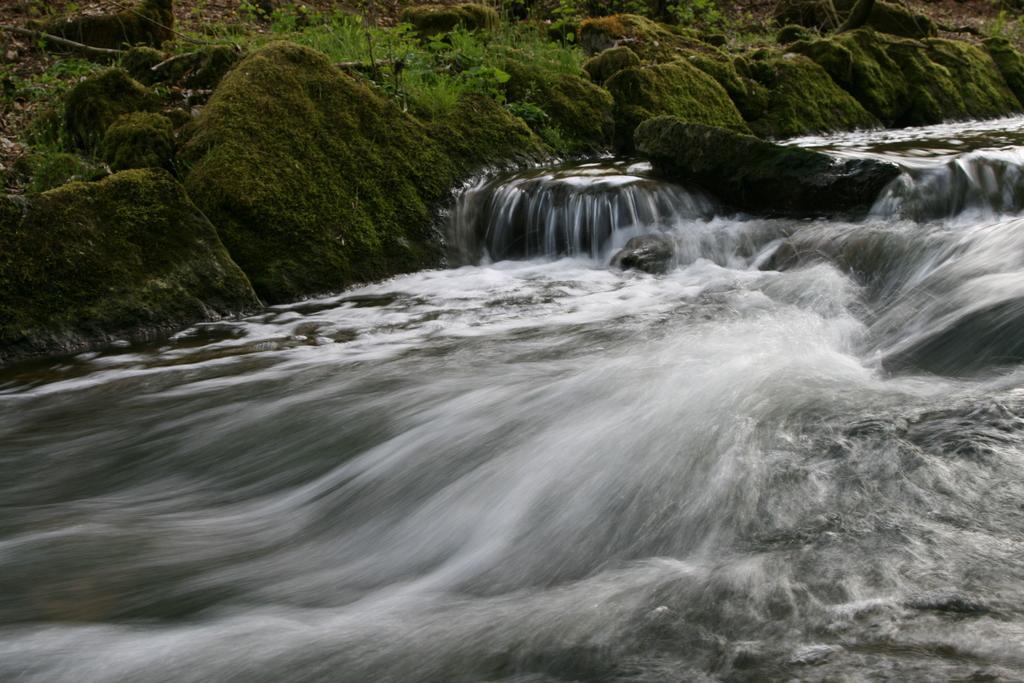How would you summarize this image in a sentence or two? There is water and there are rocks and plants at the back. 